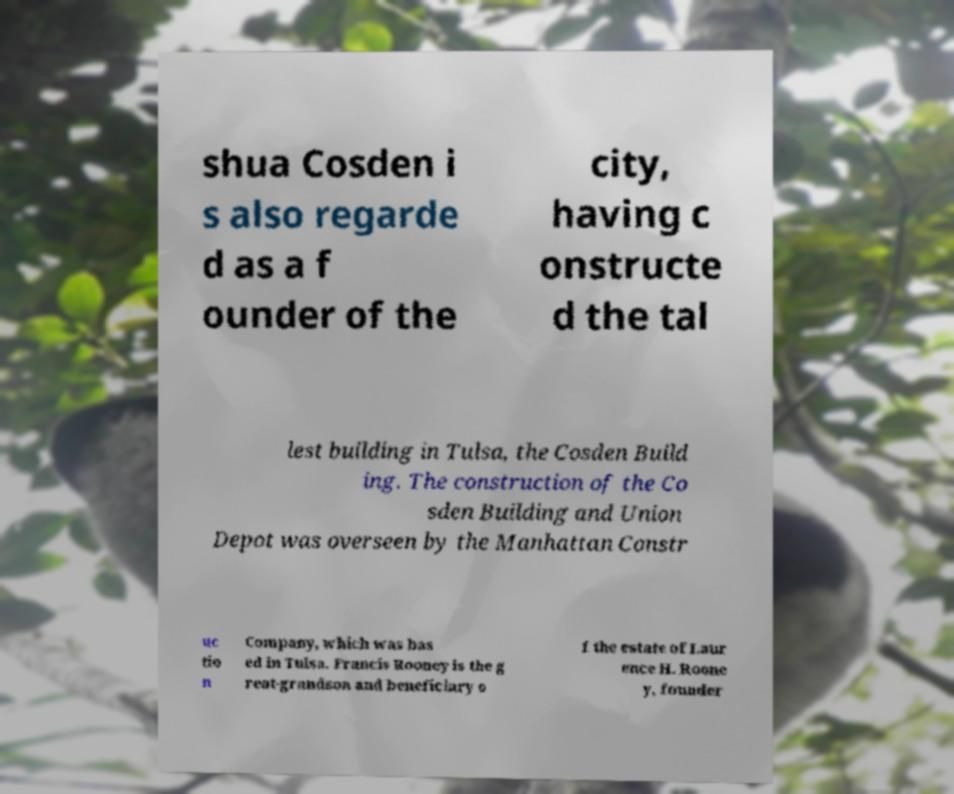I need the written content from this picture converted into text. Can you do that? shua Cosden i s also regarde d as a f ounder of the city, having c onstructe d the tal lest building in Tulsa, the Cosden Build ing. The construction of the Co sden Building and Union Depot was overseen by the Manhattan Constr uc tio n Company, which was bas ed in Tulsa. Francis Rooney is the g reat-grandson and beneficiary o f the estate of Laur ence H. Roone y, founder 